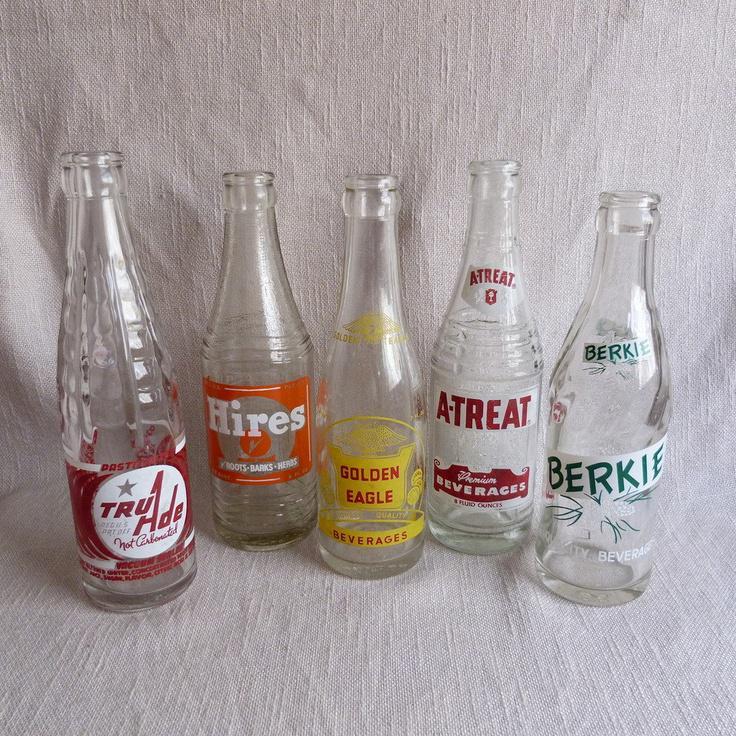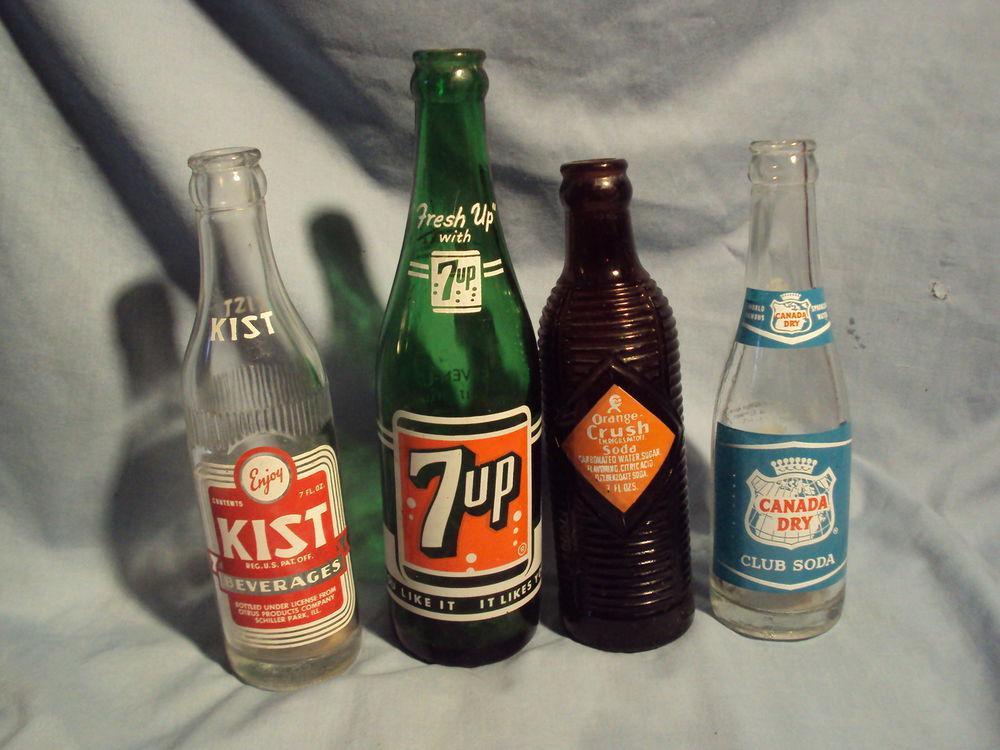The first image is the image on the left, the second image is the image on the right. Analyze the images presented: Is the assertion "There are four bottles in one image and five in the other." valid? Answer yes or no. Yes. The first image is the image on the left, the second image is the image on the right. Examine the images to the left and right. Is the description "The left image contains a staggered line of five glass bottles, and the right image contains a straighter row of four bottles." accurate? Answer yes or no. Yes. 